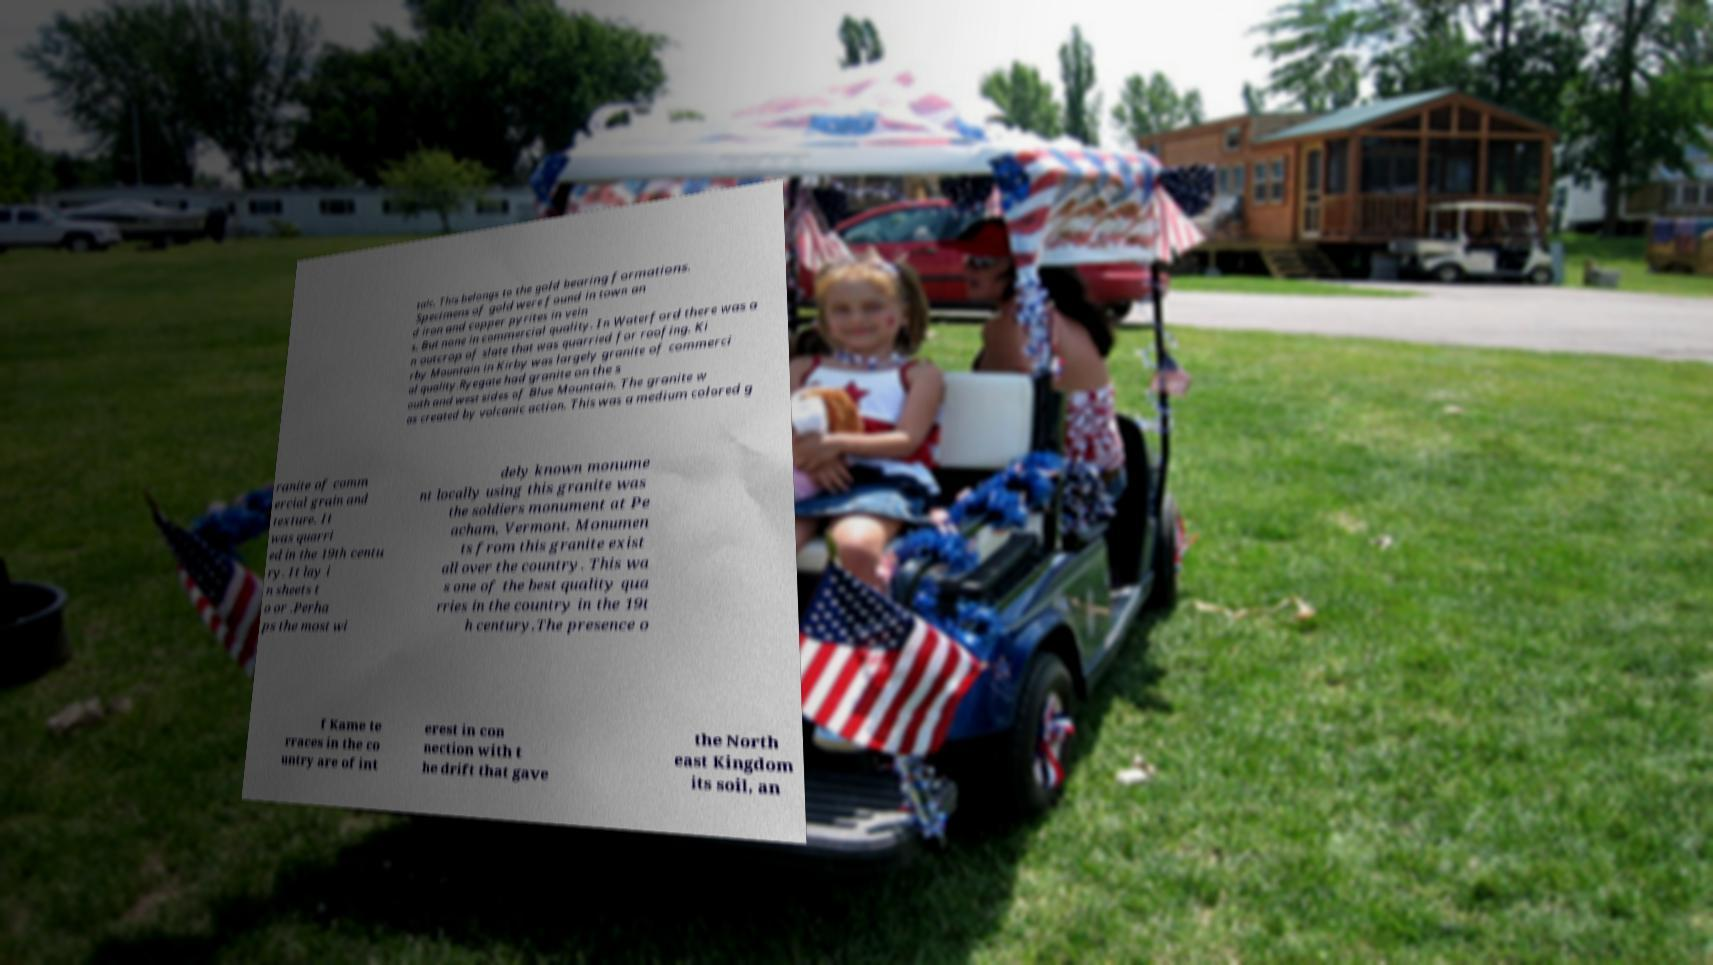Could you extract and type out the text from this image? talc. This belongs to the gold bearing formations. Specimens of gold were found in town an d iron and copper pyrites in vein s. But none in commercial quality. In Waterford there was a n outcrop of slate that was quarried for roofing. Ki rby Mountain in Kirby was largely granite of commerci al quality.Ryegate had granite on the s outh and west sides of Blue Mountain. The granite w as created by volcanic action. This was a medium colored g ranite of comm ercial grain and texture. It was quarri ed in the 19th centu ry. It lay i n sheets t o or .Perha ps the most wi dely known monume nt locally using this granite was the soldiers monument at Pe acham, Vermont. Monumen ts from this granite exist all over the country. This wa s one of the best quality qua rries in the country in the 19t h century.The presence o f Kame te rraces in the co untry are of int erest in con nection with t he drift that gave the North east Kingdom its soil, an 